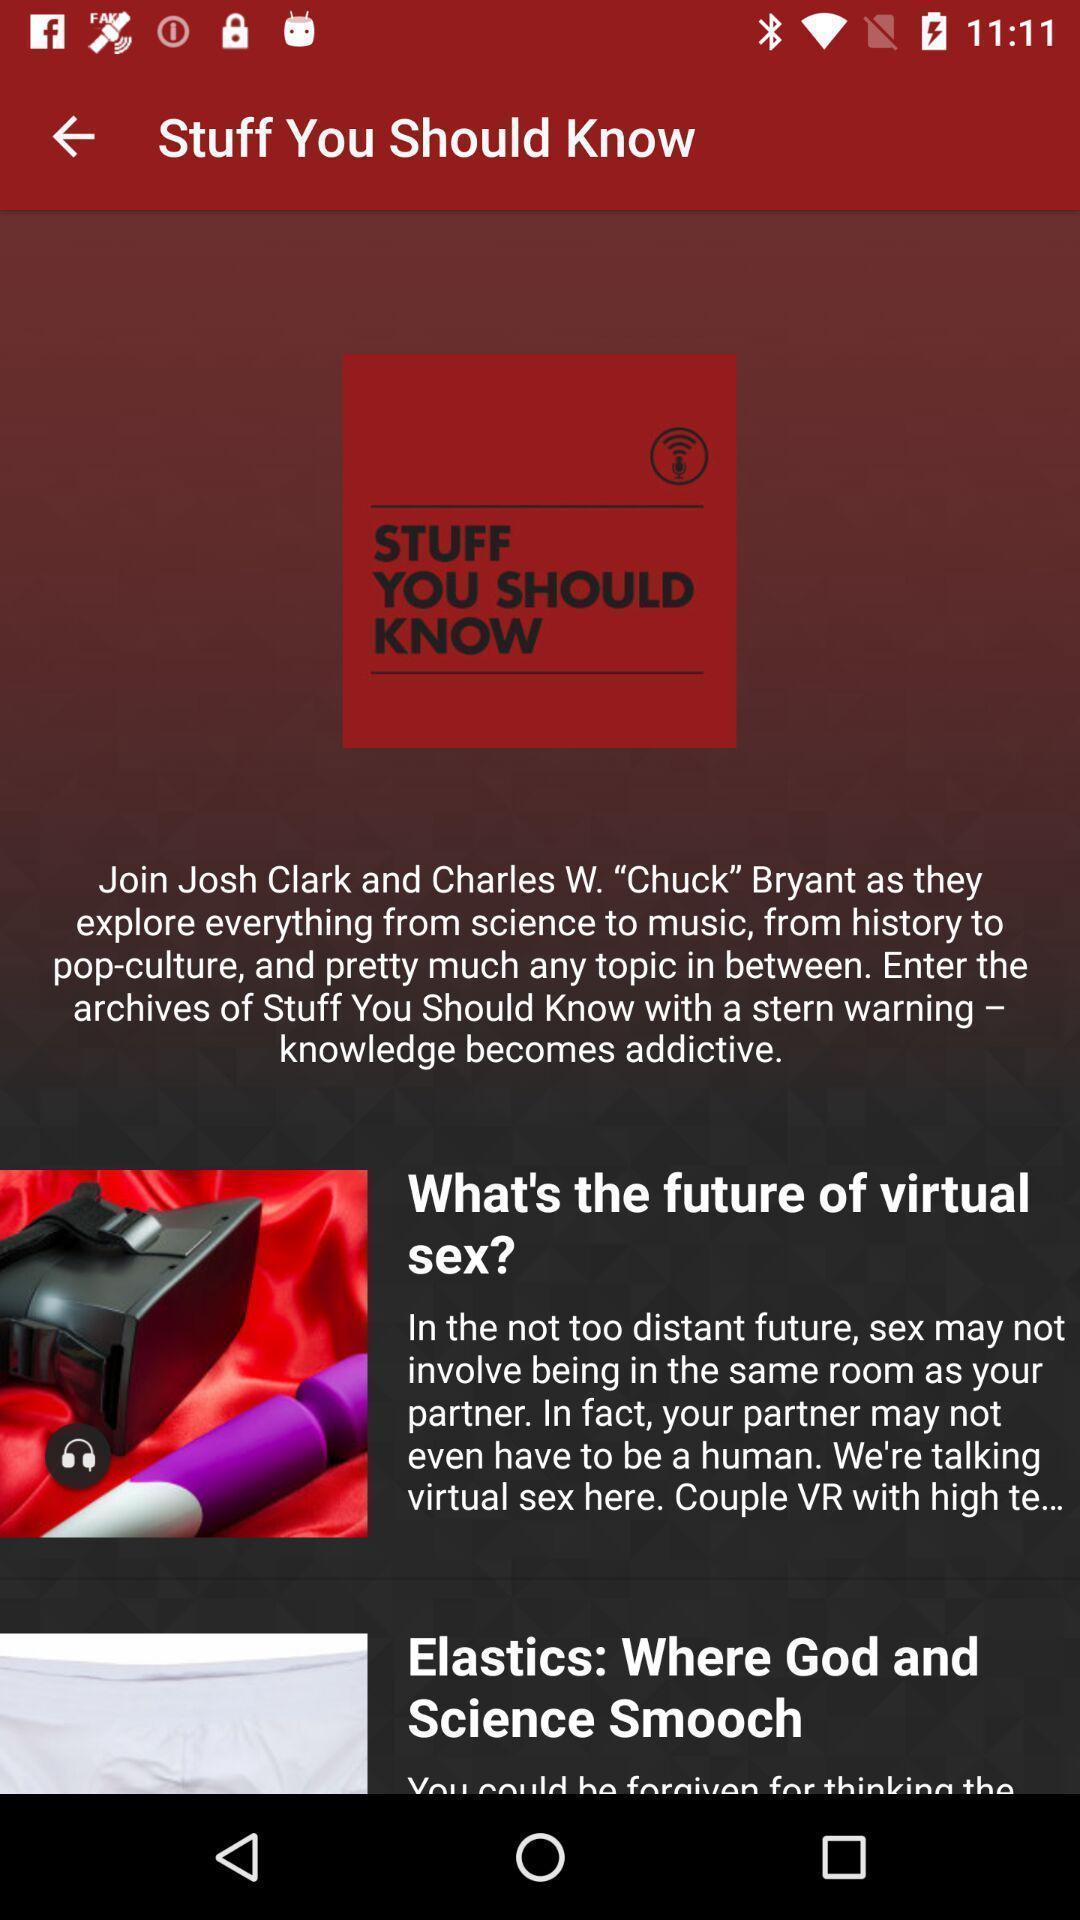Describe the key features of this screenshot. Screen shows some stuff. 